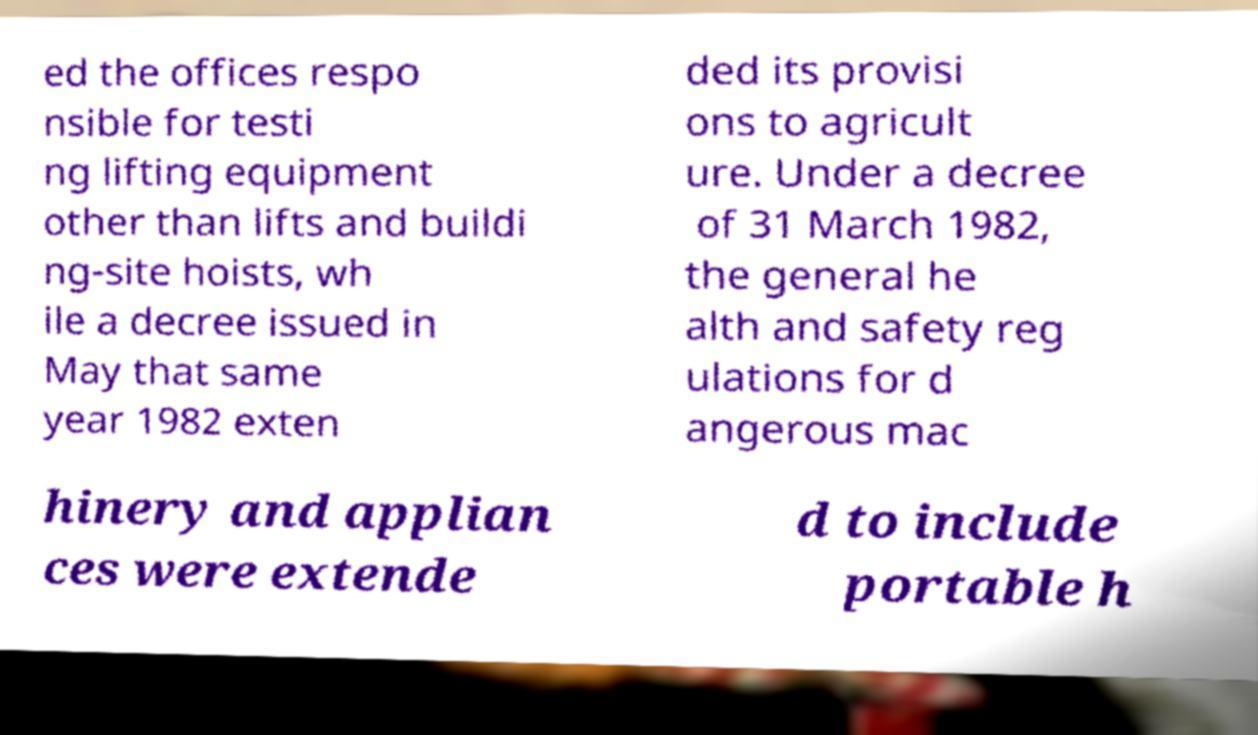Could you assist in decoding the text presented in this image and type it out clearly? ed the offices respo nsible for testi ng lifting equipment other than lifts and buildi ng-site hoists, wh ile a decree issued in May that same year 1982 exten ded its provisi ons to agricult ure. Under a decree of 31 March 1982, the general he alth and safety reg ulations for d angerous mac hinery and applian ces were extende d to include portable h 